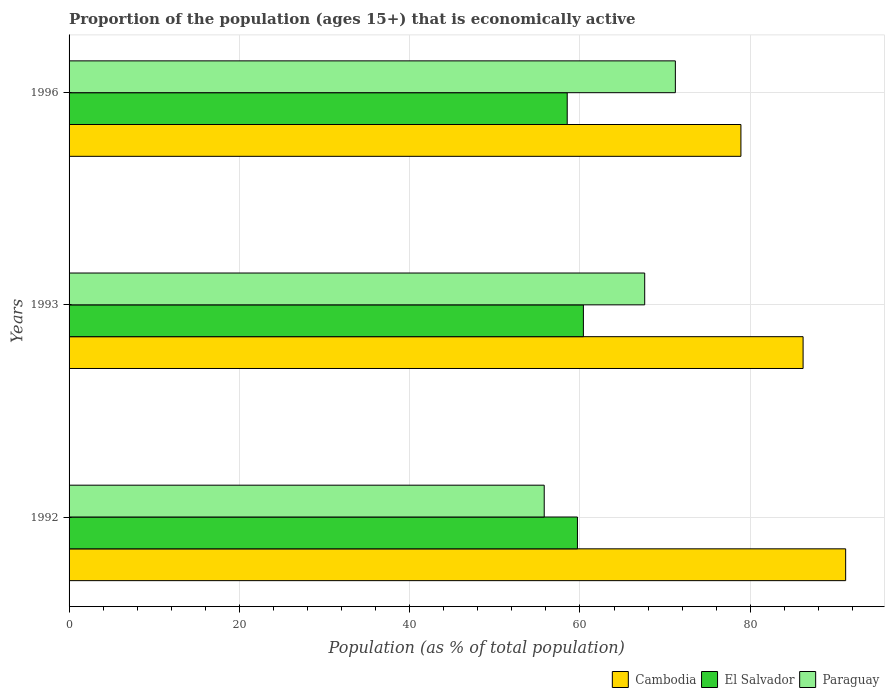How many different coloured bars are there?
Your answer should be very brief. 3. How many bars are there on the 2nd tick from the top?
Provide a short and direct response. 3. How many bars are there on the 2nd tick from the bottom?
Offer a very short reply. 3. What is the label of the 1st group of bars from the top?
Ensure brevity in your answer.  1996. What is the proportion of the population that is economically active in El Salvador in 1993?
Offer a very short reply. 60.4. Across all years, what is the maximum proportion of the population that is economically active in Paraguay?
Your answer should be very brief. 71.2. Across all years, what is the minimum proportion of the population that is economically active in Paraguay?
Make the answer very short. 55.8. In which year was the proportion of the population that is economically active in Cambodia maximum?
Offer a very short reply. 1992. What is the total proportion of the population that is economically active in Paraguay in the graph?
Ensure brevity in your answer.  194.6. What is the difference between the proportion of the population that is economically active in Paraguay in 1992 and that in 1996?
Keep it short and to the point. -15.4. What is the difference between the proportion of the population that is economically active in Paraguay in 1993 and the proportion of the population that is economically active in El Salvador in 1996?
Provide a short and direct response. 9.1. What is the average proportion of the population that is economically active in Cambodia per year?
Ensure brevity in your answer.  85.43. In the year 1996, what is the difference between the proportion of the population that is economically active in Paraguay and proportion of the population that is economically active in Cambodia?
Ensure brevity in your answer.  -7.7. What is the ratio of the proportion of the population that is economically active in Paraguay in 1992 to that in 1996?
Your answer should be very brief. 0.78. Is the difference between the proportion of the population that is economically active in Paraguay in 1992 and 1996 greater than the difference between the proportion of the population that is economically active in Cambodia in 1992 and 1996?
Keep it short and to the point. No. What is the difference between the highest and the second highest proportion of the population that is economically active in Paraguay?
Your answer should be compact. 3.6. What is the difference between the highest and the lowest proportion of the population that is economically active in El Salvador?
Keep it short and to the point. 1.9. In how many years, is the proportion of the population that is economically active in Cambodia greater than the average proportion of the population that is economically active in Cambodia taken over all years?
Give a very brief answer. 2. Is the sum of the proportion of the population that is economically active in El Salvador in 1992 and 1996 greater than the maximum proportion of the population that is economically active in Cambodia across all years?
Ensure brevity in your answer.  Yes. What does the 1st bar from the top in 1996 represents?
Keep it short and to the point. Paraguay. What does the 2nd bar from the bottom in 1993 represents?
Give a very brief answer. El Salvador. Is it the case that in every year, the sum of the proportion of the population that is economically active in El Salvador and proportion of the population that is economically active in Cambodia is greater than the proportion of the population that is economically active in Paraguay?
Offer a very short reply. Yes. How many bars are there?
Ensure brevity in your answer.  9. How many years are there in the graph?
Offer a very short reply. 3. What is the difference between two consecutive major ticks on the X-axis?
Keep it short and to the point. 20. Does the graph contain grids?
Ensure brevity in your answer.  Yes. How many legend labels are there?
Provide a succinct answer. 3. How are the legend labels stacked?
Your answer should be compact. Horizontal. What is the title of the graph?
Your answer should be compact. Proportion of the population (ages 15+) that is economically active. Does "Isle of Man" appear as one of the legend labels in the graph?
Offer a very short reply. No. What is the label or title of the X-axis?
Your answer should be very brief. Population (as % of total population). What is the label or title of the Y-axis?
Provide a succinct answer. Years. What is the Population (as % of total population) in Cambodia in 1992?
Your answer should be very brief. 91.2. What is the Population (as % of total population) in El Salvador in 1992?
Provide a short and direct response. 59.7. What is the Population (as % of total population) of Paraguay in 1992?
Offer a very short reply. 55.8. What is the Population (as % of total population) in Cambodia in 1993?
Keep it short and to the point. 86.2. What is the Population (as % of total population) in El Salvador in 1993?
Your answer should be very brief. 60.4. What is the Population (as % of total population) of Paraguay in 1993?
Provide a succinct answer. 67.6. What is the Population (as % of total population) in Cambodia in 1996?
Provide a succinct answer. 78.9. What is the Population (as % of total population) of El Salvador in 1996?
Make the answer very short. 58.5. What is the Population (as % of total population) in Paraguay in 1996?
Provide a short and direct response. 71.2. Across all years, what is the maximum Population (as % of total population) in Cambodia?
Make the answer very short. 91.2. Across all years, what is the maximum Population (as % of total population) in El Salvador?
Make the answer very short. 60.4. Across all years, what is the maximum Population (as % of total population) of Paraguay?
Keep it short and to the point. 71.2. Across all years, what is the minimum Population (as % of total population) of Cambodia?
Your answer should be very brief. 78.9. Across all years, what is the minimum Population (as % of total population) of El Salvador?
Provide a succinct answer. 58.5. Across all years, what is the minimum Population (as % of total population) in Paraguay?
Provide a short and direct response. 55.8. What is the total Population (as % of total population) of Cambodia in the graph?
Your response must be concise. 256.3. What is the total Population (as % of total population) of El Salvador in the graph?
Your response must be concise. 178.6. What is the total Population (as % of total population) in Paraguay in the graph?
Provide a short and direct response. 194.6. What is the difference between the Population (as % of total population) in El Salvador in 1992 and that in 1993?
Provide a short and direct response. -0.7. What is the difference between the Population (as % of total population) of Cambodia in 1992 and that in 1996?
Provide a succinct answer. 12.3. What is the difference between the Population (as % of total population) of Paraguay in 1992 and that in 1996?
Ensure brevity in your answer.  -15.4. What is the difference between the Population (as % of total population) in El Salvador in 1993 and that in 1996?
Offer a terse response. 1.9. What is the difference between the Population (as % of total population) in Cambodia in 1992 and the Population (as % of total population) in El Salvador in 1993?
Provide a succinct answer. 30.8. What is the difference between the Population (as % of total population) of Cambodia in 1992 and the Population (as % of total population) of Paraguay in 1993?
Offer a very short reply. 23.6. What is the difference between the Population (as % of total population) in El Salvador in 1992 and the Population (as % of total population) in Paraguay in 1993?
Ensure brevity in your answer.  -7.9. What is the difference between the Population (as % of total population) of Cambodia in 1992 and the Population (as % of total population) of El Salvador in 1996?
Your response must be concise. 32.7. What is the difference between the Population (as % of total population) in Cambodia in 1992 and the Population (as % of total population) in Paraguay in 1996?
Your response must be concise. 20. What is the difference between the Population (as % of total population) of El Salvador in 1992 and the Population (as % of total population) of Paraguay in 1996?
Ensure brevity in your answer.  -11.5. What is the difference between the Population (as % of total population) of Cambodia in 1993 and the Population (as % of total population) of El Salvador in 1996?
Give a very brief answer. 27.7. What is the average Population (as % of total population) of Cambodia per year?
Give a very brief answer. 85.43. What is the average Population (as % of total population) of El Salvador per year?
Offer a terse response. 59.53. What is the average Population (as % of total population) in Paraguay per year?
Offer a terse response. 64.87. In the year 1992, what is the difference between the Population (as % of total population) of Cambodia and Population (as % of total population) of El Salvador?
Offer a terse response. 31.5. In the year 1992, what is the difference between the Population (as % of total population) of Cambodia and Population (as % of total population) of Paraguay?
Give a very brief answer. 35.4. In the year 1992, what is the difference between the Population (as % of total population) of El Salvador and Population (as % of total population) of Paraguay?
Your response must be concise. 3.9. In the year 1993, what is the difference between the Population (as % of total population) in Cambodia and Population (as % of total population) in El Salvador?
Offer a terse response. 25.8. In the year 1993, what is the difference between the Population (as % of total population) in Cambodia and Population (as % of total population) in Paraguay?
Provide a succinct answer. 18.6. In the year 1996, what is the difference between the Population (as % of total population) in Cambodia and Population (as % of total population) in El Salvador?
Ensure brevity in your answer.  20.4. In the year 1996, what is the difference between the Population (as % of total population) of Cambodia and Population (as % of total population) of Paraguay?
Offer a very short reply. 7.7. What is the ratio of the Population (as % of total population) of Cambodia in 1992 to that in 1993?
Keep it short and to the point. 1.06. What is the ratio of the Population (as % of total population) in El Salvador in 1992 to that in 1993?
Give a very brief answer. 0.99. What is the ratio of the Population (as % of total population) of Paraguay in 1992 to that in 1993?
Your response must be concise. 0.83. What is the ratio of the Population (as % of total population) of Cambodia in 1992 to that in 1996?
Provide a succinct answer. 1.16. What is the ratio of the Population (as % of total population) in El Salvador in 1992 to that in 1996?
Your answer should be compact. 1.02. What is the ratio of the Population (as % of total population) in Paraguay in 1992 to that in 1996?
Make the answer very short. 0.78. What is the ratio of the Population (as % of total population) in Cambodia in 1993 to that in 1996?
Your answer should be very brief. 1.09. What is the ratio of the Population (as % of total population) in El Salvador in 1993 to that in 1996?
Your response must be concise. 1.03. What is the ratio of the Population (as % of total population) of Paraguay in 1993 to that in 1996?
Offer a terse response. 0.95. What is the difference between the highest and the second highest Population (as % of total population) of El Salvador?
Keep it short and to the point. 0.7. What is the difference between the highest and the lowest Population (as % of total population) in Cambodia?
Your response must be concise. 12.3. What is the difference between the highest and the lowest Population (as % of total population) in El Salvador?
Provide a succinct answer. 1.9. What is the difference between the highest and the lowest Population (as % of total population) of Paraguay?
Offer a very short reply. 15.4. 